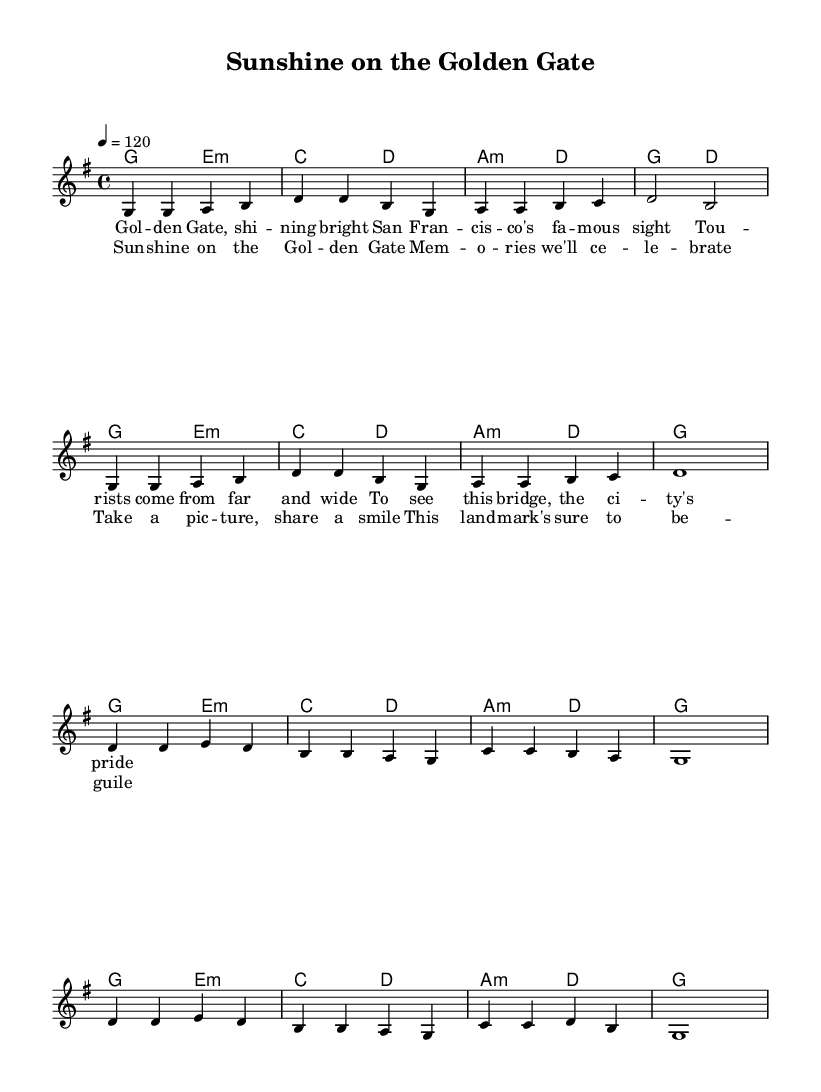What is the key signature of this music? The key signature is G major, indicated by one sharp on the staff. Space for any additional notes can be noted.
Answer: G major What is the time signature of this music? The time signature is 4/4, as shown at the beginning of the sheet music. This indicates there are four beats in each measure.
Answer: 4/4 What is the tempo marking for this piece? The tempo marking is 120 beats per minute, indicated at the beginning of the score. This means the piece should be played at a moderate pace.
Answer: 120 How many measures are in the first chorus? The first chorus consists of four measures and can be counted in the notation as there are four distinct groupings of notes and rests in that section.
Answer: 4 What type of chord is used in the second measure? The second measure features a C major chord, which is identified by the notes making up the chord indicated in the chord symbols above the staff.
Answer: C major How does the melody progress in the first line? The melody in the first line ascends from G to B and then descends back to G, demonstrating a pattern of ascending and descending notes in the scale.
Answer: Ascending and descending How does the lyrics relate to the song's theme? The lyrics reflect a celebratory theme surrounding a famous landmark, highlighting positive memories associated with it, as indicated in both the verse and chorus sections.
Answer: Celebratory 